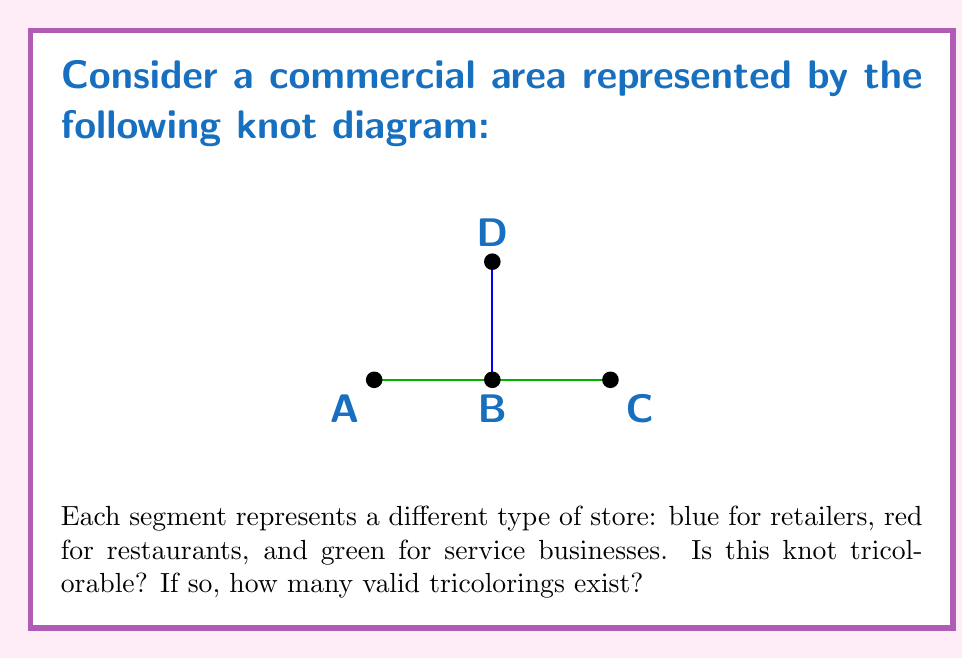Provide a solution to this math problem. To determine if a knot is tricolorable and count the number of valid tricolorings, we follow these steps:

1) First, recall the rules for tricolorability:
   a) Each arc must be colored with one of three colors.
   b) At each crossing, either all three colors must be present, or all arcs must have the same color.

2) In this knot diagram, we have four arcs: AB, BC, CA, and DB.

3) Let's start by assigning colors to the given arcs:
   AB: Blue
   BC: Red
   CA: Green
   DB: Blue

4) Now, we need to check if this coloring satisfies the tricolorability conditions at each crossing:
   - At crossing B: We have blue (AB), red (BC), and blue (DB). This is valid as all arcs can be the same color.

5) Since all crossings satisfy the tricolorability conditions, this knot is indeed tricolorable.

6) To count the number of valid tricolorings, we need to consider all possible color assignments:
   - We have 3 choices for the first arc.
   - For the second arc, we have 2 choices (it can't be the same as the first).
   - The third arc's color is then forced to be the remaining color.
   - The fourth arc (DB) must be the same color as AB to satisfy the crossing condition.

7) Therefore, the total number of valid tricolorings is $3 \times 2 = 6$.

These 6 tricolorings represent different distributions of store types in the commercial area, which could be useful for analyzing the balance and variety of businesses in the local economy.
Answer: Yes, tricolorable; 6 valid tricolorings 